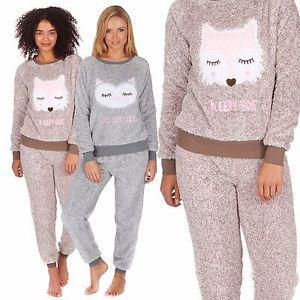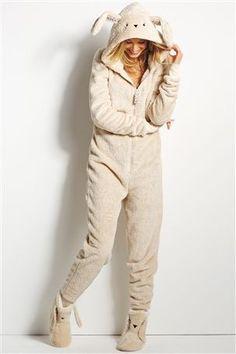The first image is the image on the left, the second image is the image on the right. For the images shown, is this caption "More than one pajama set has a depiction of an animal on the top." true? Answer yes or no. Yes. The first image is the image on the left, the second image is the image on the right. Assess this claim about the two images: "Women are wearing shirts with cartoon animals sleeping on them in one of the images.". Correct or not? Answer yes or no. Yes. 